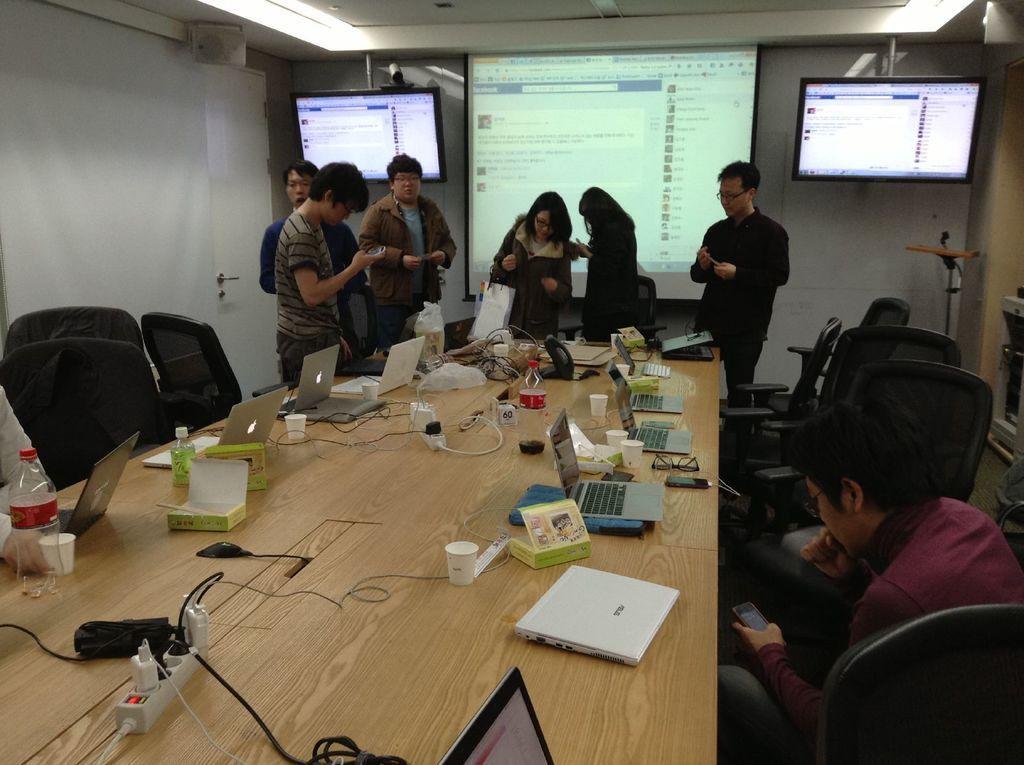Describe this image in one or two sentences. Here we can see a few people standing. Here we can see a televisions which are fixed to a wall. This is a wooden table where a laptop, an extension box and mobile phones are kept on it. There is a man on the right side sitting on a chair and he is seeing something in his phone. 